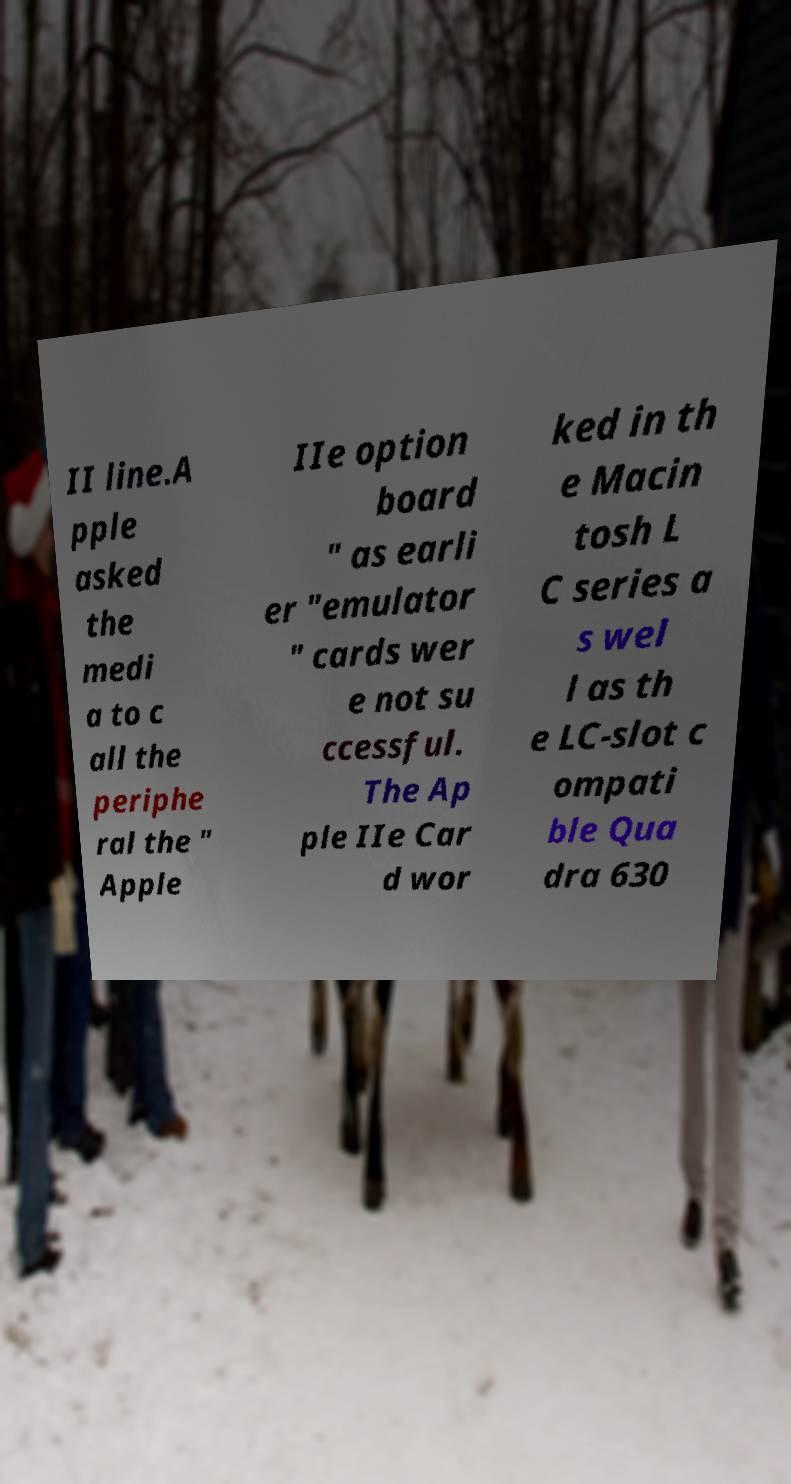Could you extract and type out the text from this image? II line.A pple asked the medi a to c all the periphe ral the " Apple IIe option board " as earli er "emulator " cards wer e not su ccessful. The Ap ple IIe Car d wor ked in th e Macin tosh L C series a s wel l as th e LC-slot c ompati ble Qua dra 630 